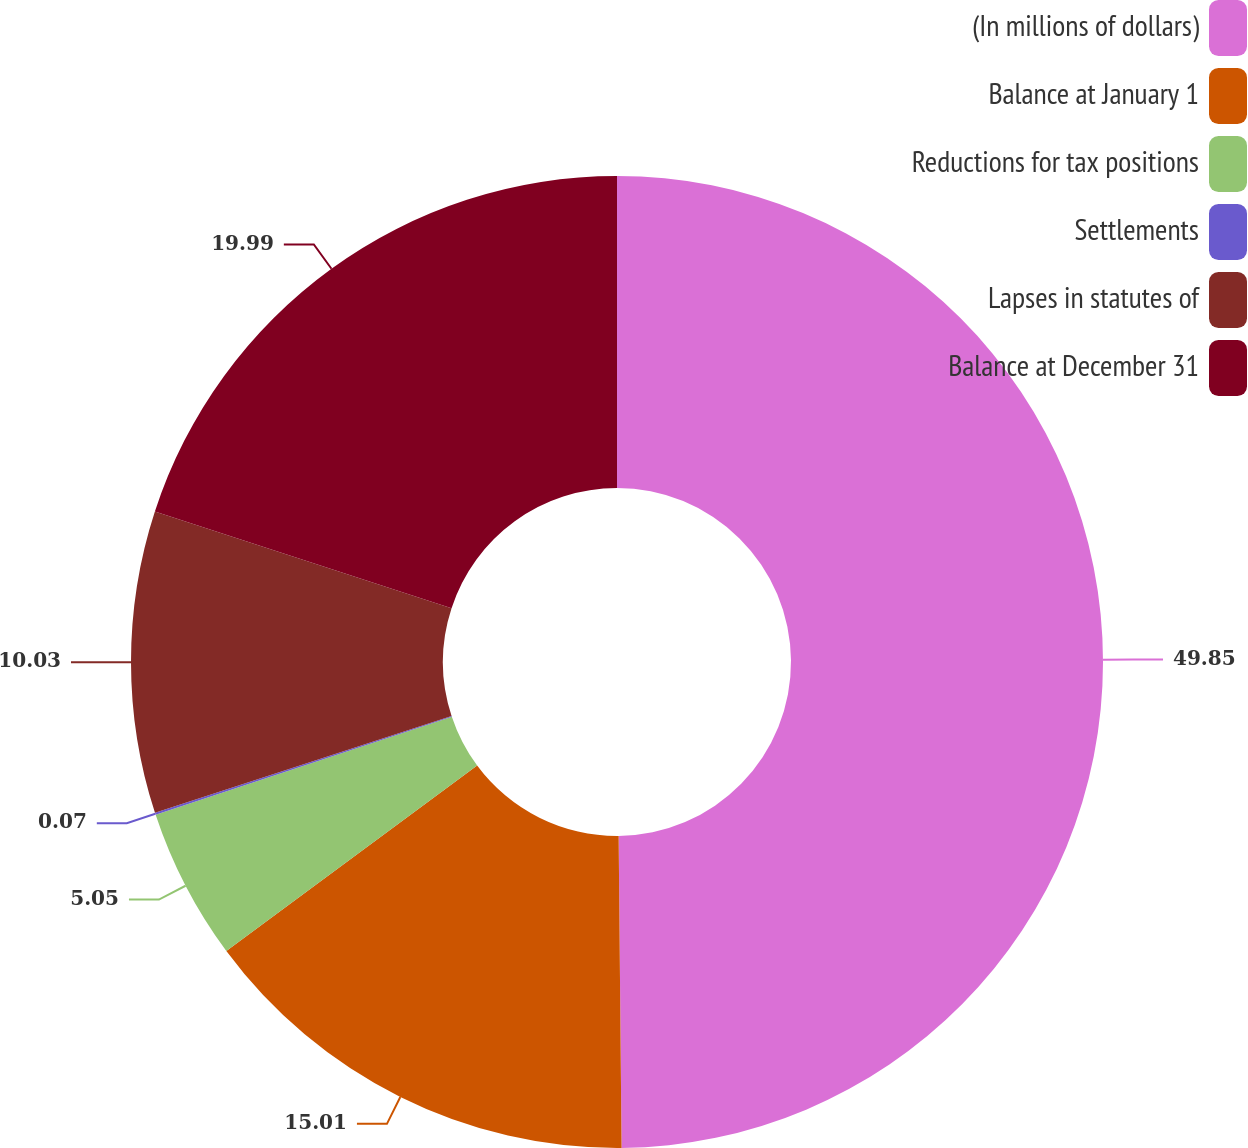<chart> <loc_0><loc_0><loc_500><loc_500><pie_chart><fcel>(In millions of dollars)<fcel>Balance at January 1<fcel>Reductions for tax positions<fcel>Settlements<fcel>Lapses in statutes of<fcel>Balance at December 31<nl><fcel>49.85%<fcel>15.01%<fcel>5.05%<fcel>0.07%<fcel>10.03%<fcel>19.99%<nl></chart> 